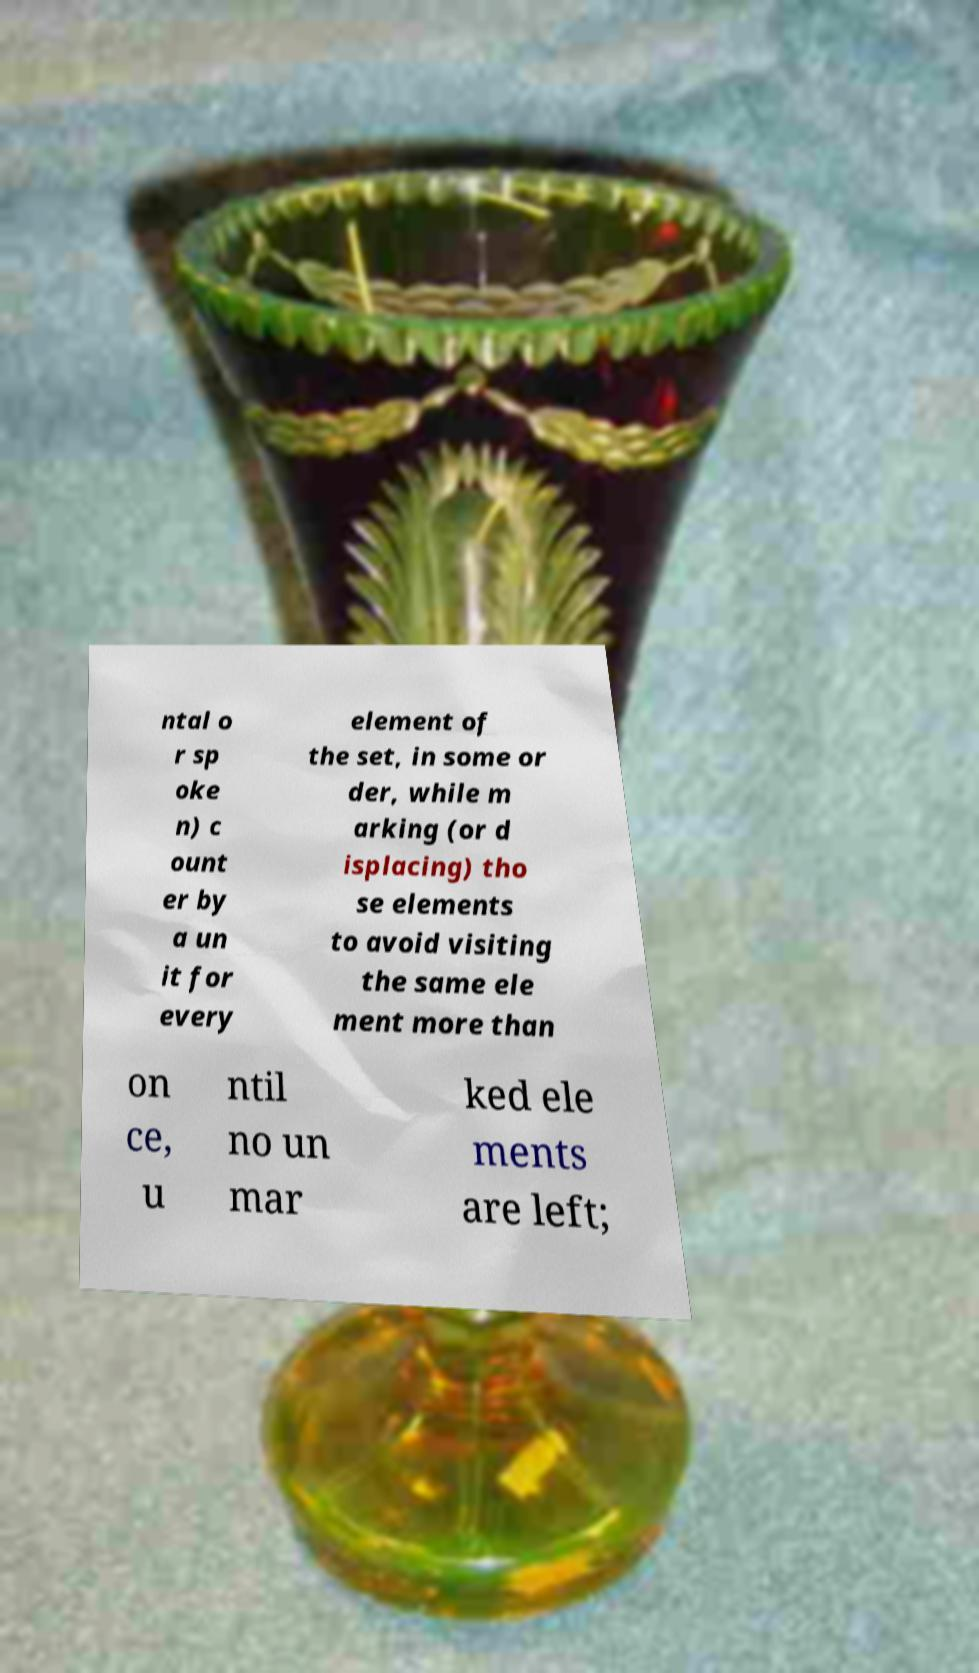Please read and relay the text visible in this image. What does it say? ntal o r sp oke n) c ount er by a un it for every element of the set, in some or der, while m arking (or d isplacing) tho se elements to avoid visiting the same ele ment more than on ce, u ntil no un mar ked ele ments are left; 